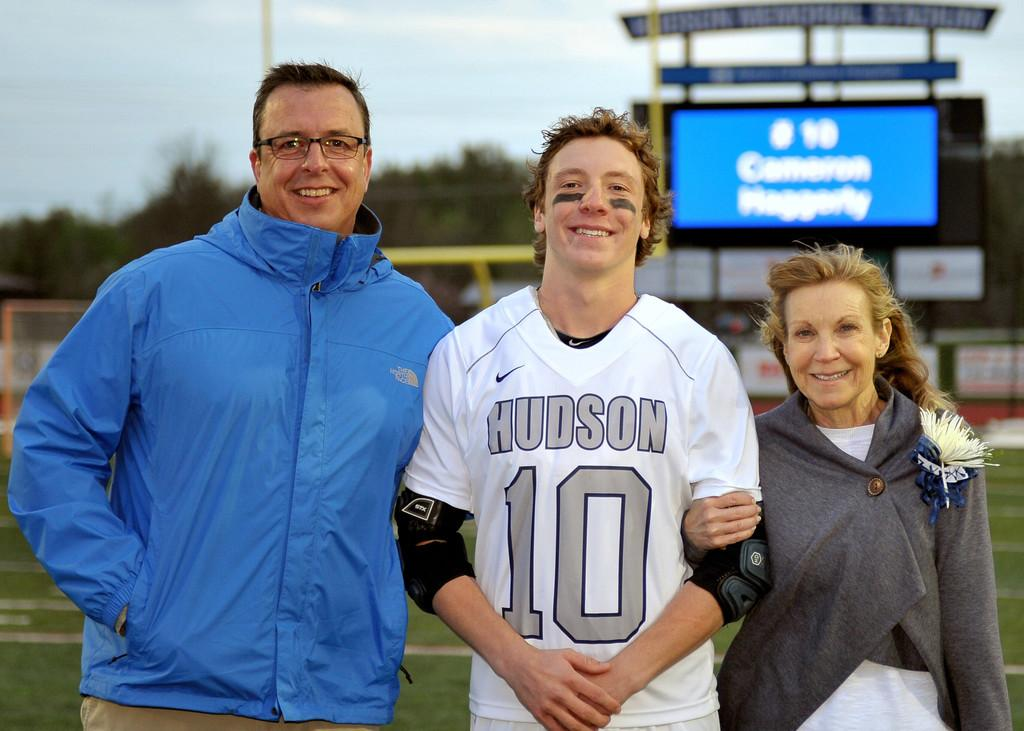<image>
Describe the image concisely. A boy in a Hudson jersey with a man and a woman on each side of him 